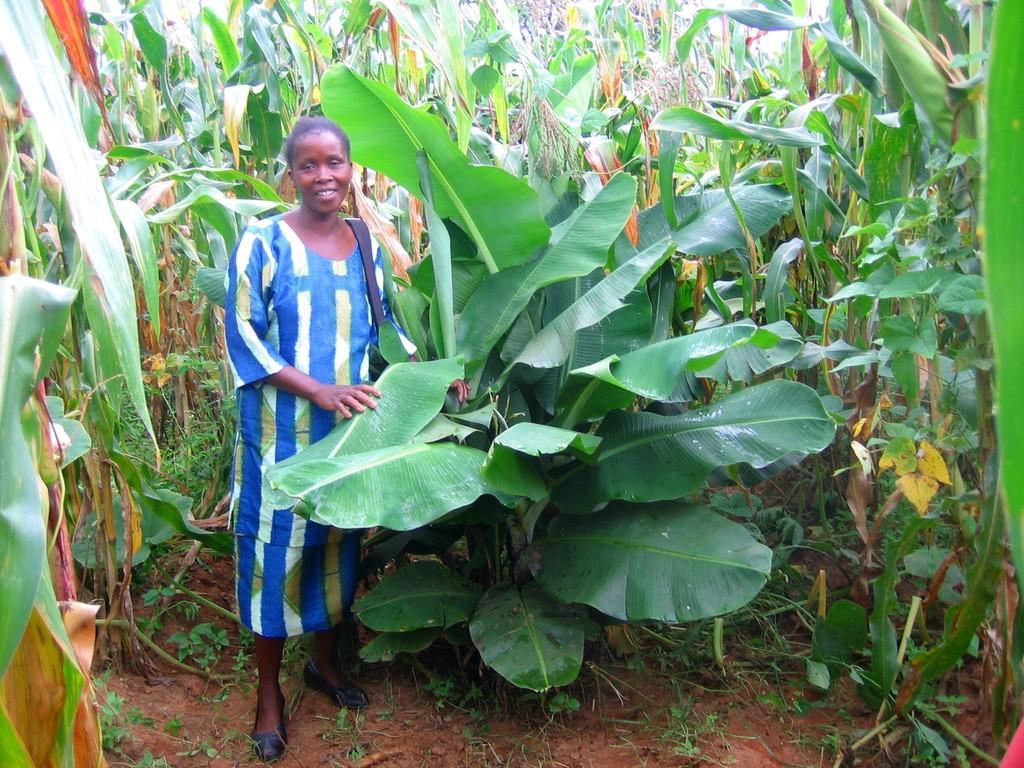Could you give a brief overview of what you see in this image? In this picture we can see a woman wearing a bag and standing on the land, she is holding leaves, around we can see some plants. 